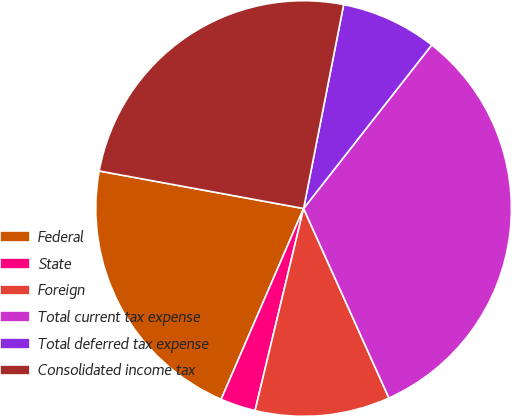Convert chart. <chart><loc_0><loc_0><loc_500><loc_500><pie_chart><fcel>Federal<fcel>State<fcel>Foreign<fcel>Total current tax expense<fcel>Total deferred tax expense<fcel>Consolidated income tax<nl><fcel>21.4%<fcel>2.74%<fcel>10.49%<fcel>32.69%<fcel>7.49%<fcel>25.2%<nl></chart> 